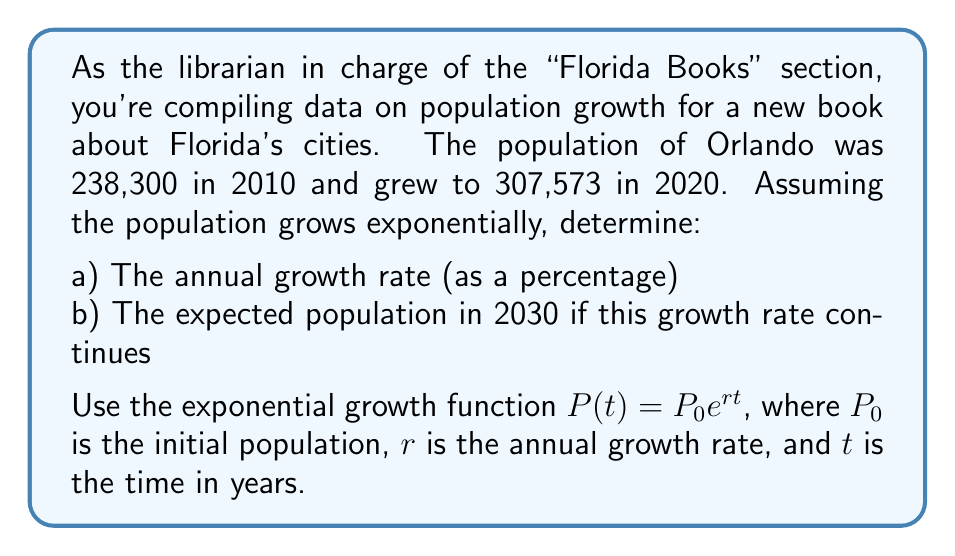Provide a solution to this math problem. Let's approach this problem step by step:

a) To find the annual growth rate:

1. We'll use the exponential growth function: $P(t) = P_0 e^{rt}$
   Where $P_0 = 238,300$ (population in 2010)
   $P(10) = 307,573$ (population in 2020)
   $t = 10$ years

2. Plug these values into the equation:
   $307,573 = 238,300 e^{10r}$

3. Divide both sides by 238,300:
   $\frac{307,573}{238,300} = e^{10r}$

4. Take the natural log of both sides:
   $\ln(\frac{307,573}{238,300}) = 10r$

5. Solve for $r$:
   $r = \frac{\ln(\frac{307,573}{238,300})}{10} \approx 0.0257$

6. Convert to a percentage:
   $0.0257 \times 100\% = 2.57\%$

b) To find the expected population in 2030:

1. Use the growth rate we just calculated: $r = 0.0257$
2. The initial population $P_0 = 238,300$ (2010 population)
3. Time $t = 20$ years (from 2010 to 2030)

4. Plug these into the exponential growth function:
   $P(20) = 238,300 e^{0.0257 \times 20}$

5. Calculate:
   $P(20) = 238,300 e^{0.514} \approx 397,030$
Answer: a) The annual growth rate is approximately 2.57%
b) The expected population in 2030 is approximately 397,030 